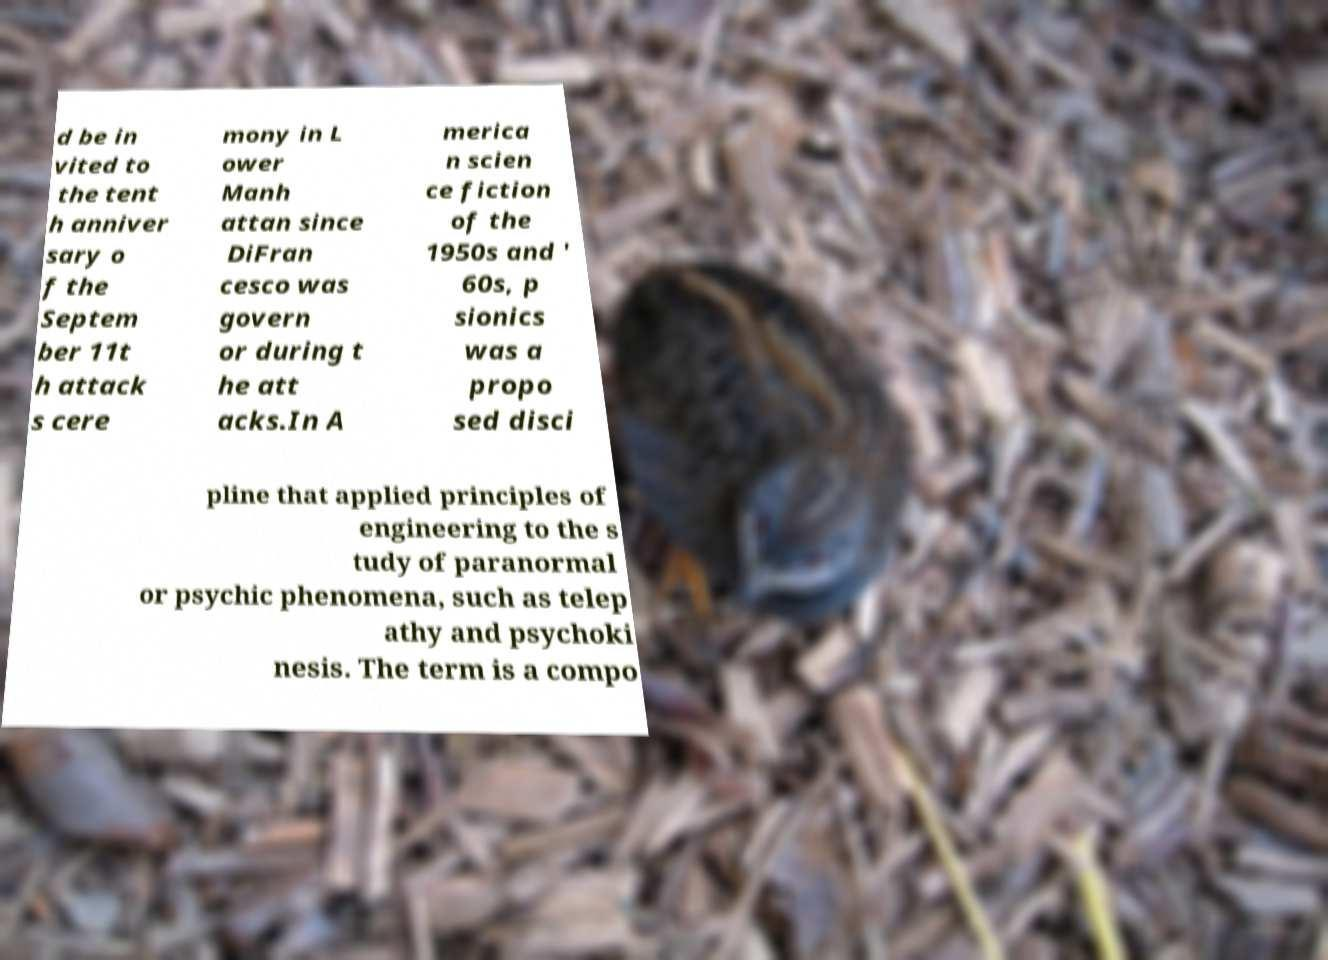Could you assist in decoding the text presented in this image and type it out clearly? d be in vited to the tent h anniver sary o f the Septem ber 11t h attack s cere mony in L ower Manh attan since DiFran cesco was govern or during t he att acks.In A merica n scien ce fiction of the 1950s and ' 60s, p sionics was a propo sed disci pline that applied principles of engineering to the s tudy of paranormal or psychic phenomena, such as telep athy and psychoki nesis. The term is a compo 